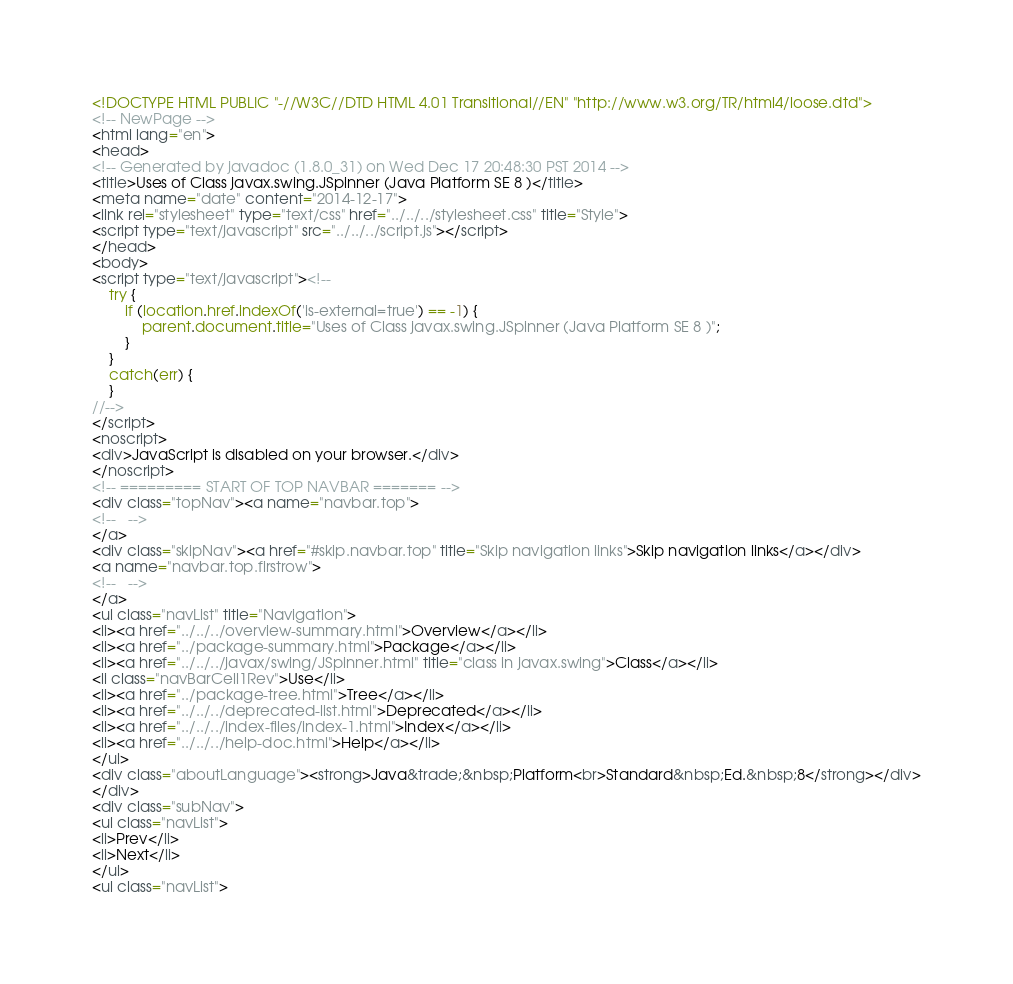Convert code to text. <code><loc_0><loc_0><loc_500><loc_500><_HTML_><!DOCTYPE HTML PUBLIC "-//W3C//DTD HTML 4.01 Transitional//EN" "http://www.w3.org/TR/html4/loose.dtd">
<!-- NewPage -->
<html lang="en">
<head>
<!-- Generated by javadoc (1.8.0_31) on Wed Dec 17 20:48:30 PST 2014 -->
<title>Uses of Class javax.swing.JSpinner (Java Platform SE 8 )</title>
<meta name="date" content="2014-12-17">
<link rel="stylesheet" type="text/css" href="../../../stylesheet.css" title="Style">
<script type="text/javascript" src="../../../script.js"></script>
</head>
<body>
<script type="text/javascript"><!--
    try {
        if (location.href.indexOf('is-external=true') == -1) {
            parent.document.title="Uses of Class javax.swing.JSpinner (Java Platform SE 8 )";
        }
    }
    catch(err) {
    }
//-->
</script>
<noscript>
<div>JavaScript is disabled on your browser.</div>
</noscript>
<!-- ========= START OF TOP NAVBAR ======= -->
<div class="topNav"><a name="navbar.top">
<!--   -->
</a>
<div class="skipNav"><a href="#skip.navbar.top" title="Skip navigation links">Skip navigation links</a></div>
<a name="navbar.top.firstrow">
<!--   -->
</a>
<ul class="navList" title="Navigation">
<li><a href="../../../overview-summary.html">Overview</a></li>
<li><a href="../package-summary.html">Package</a></li>
<li><a href="../../../javax/swing/JSpinner.html" title="class in javax.swing">Class</a></li>
<li class="navBarCell1Rev">Use</li>
<li><a href="../package-tree.html">Tree</a></li>
<li><a href="../../../deprecated-list.html">Deprecated</a></li>
<li><a href="../../../index-files/index-1.html">Index</a></li>
<li><a href="../../../help-doc.html">Help</a></li>
</ul>
<div class="aboutLanguage"><strong>Java&trade;&nbsp;Platform<br>Standard&nbsp;Ed.&nbsp;8</strong></div>
</div>
<div class="subNav">
<ul class="navList">
<li>Prev</li>
<li>Next</li>
</ul>
<ul class="navList"></code> 